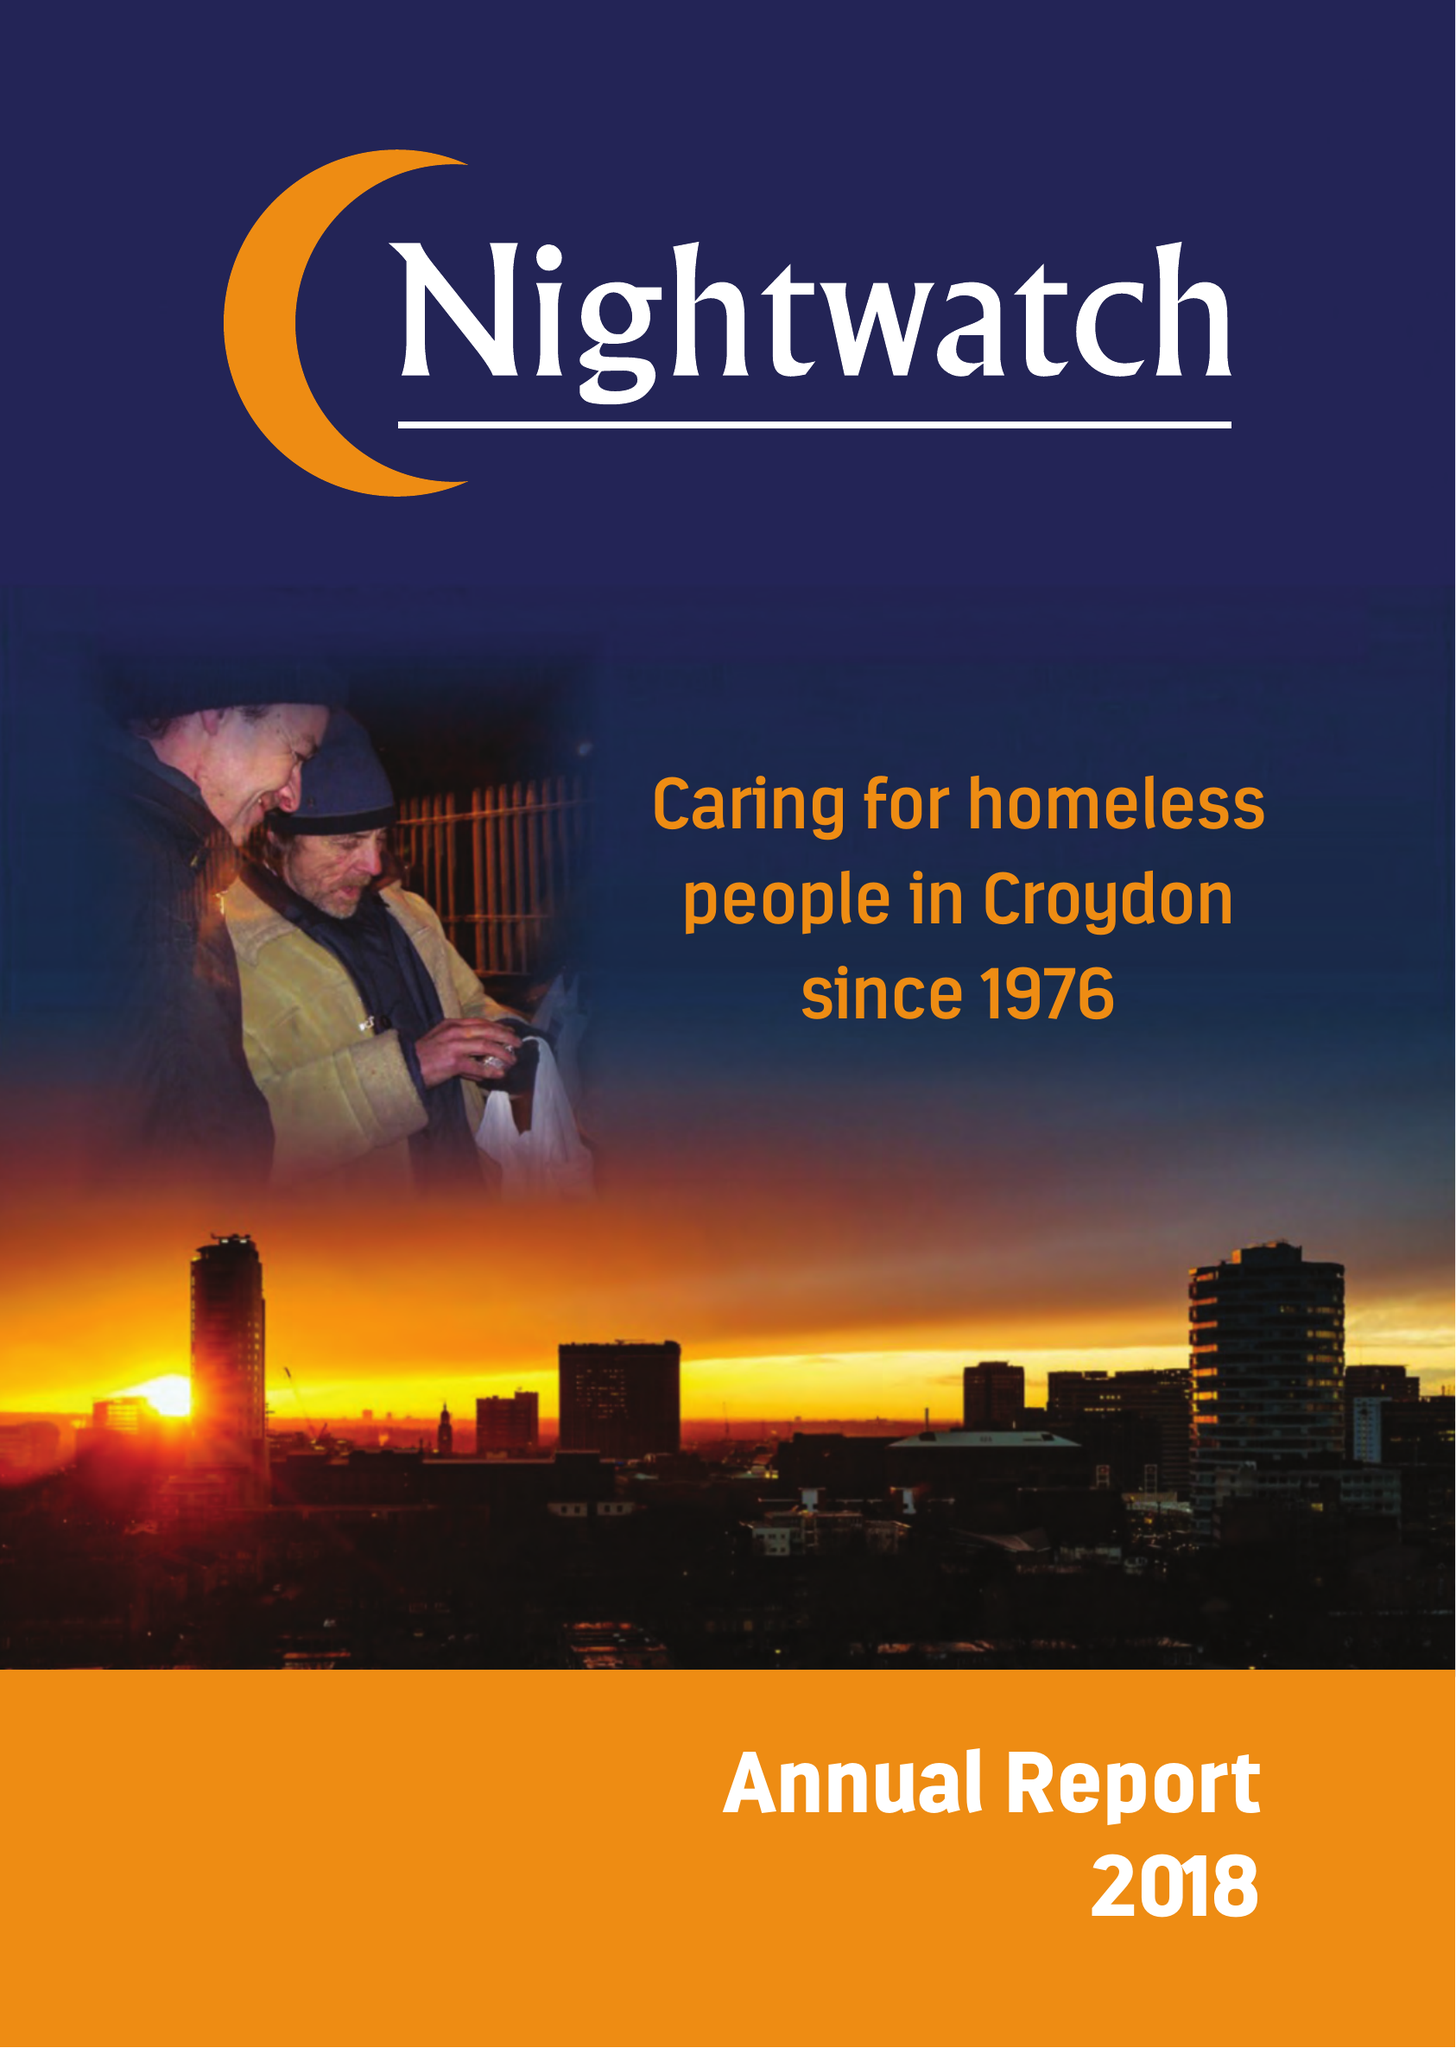What is the value for the charity_name?
Answer the question using a single word or phrase. Nightwatch 